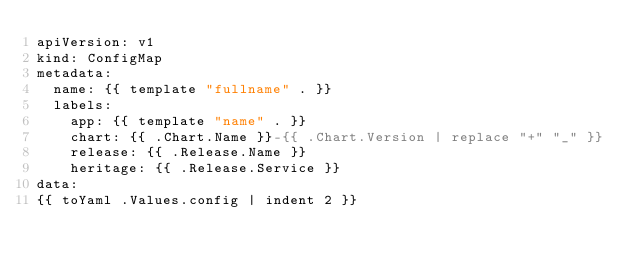<code> <loc_0><loc_0><loc_500><loc_500><_YAML_>apiVersion: v1
kind: ConfigMap
metadata:
  name: {{ template "fullname" . }}
  labels:
    app: {{ template "name" . }}
    chart: {{ .Chart.Name }}-{{ .Chart.Version | replace "+" "_" }}
    release: {{ .Release.Name }}
    heritage: {{ .Release.Service }}
data:
{{ toYaml .Values.config | indent 2 }}


</code> 